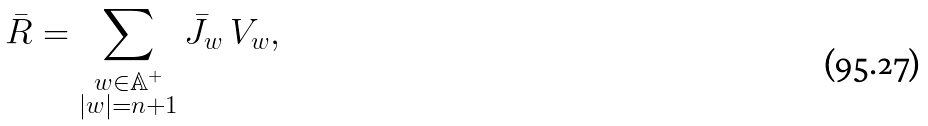Convert formula to latex. <formula><loc_0><loc_0><loc_500><loc_500>\bar { R } = \sum _ { \substack { w \in \mathbb { A } ^ { + } \\ | w | = n + 1 } } \bar { J } _ { w } \, V _ { w } ,</formula> 